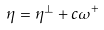Convert formula to latex. <formula><loc_0><loc_0><loc_500><loc_500>\eta = \eta ^ { \perp } + c \omega ^ { + }</formula> 